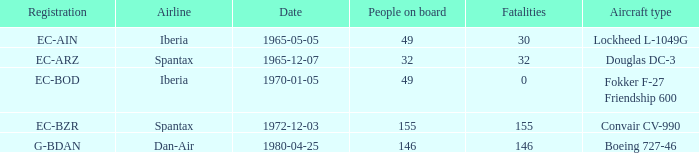How many fatalities shows for the lockheed l-1049g? 30.0. 